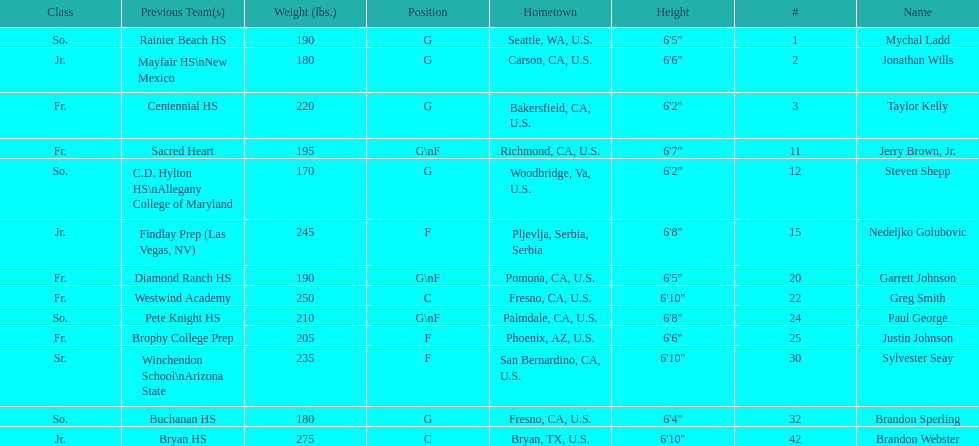What are the names of the basketball team players? Mychal Ladd, Jonathan Wills, Taylor Kelly, Jerry Brown, Jr., Steven Shepp, Nedeljko Golubovic, Garrett Johnson, Greg Smith, Paul George, Justin Johnson, Sylvester Seay, Brandon Sperling, Brandon Webster. Of these identify paul george and greg smith Greg Smith, Paul George. What are their corresponding heights? 6'10", 6'8". To who does the larger height correspond to? Greg Smith. 